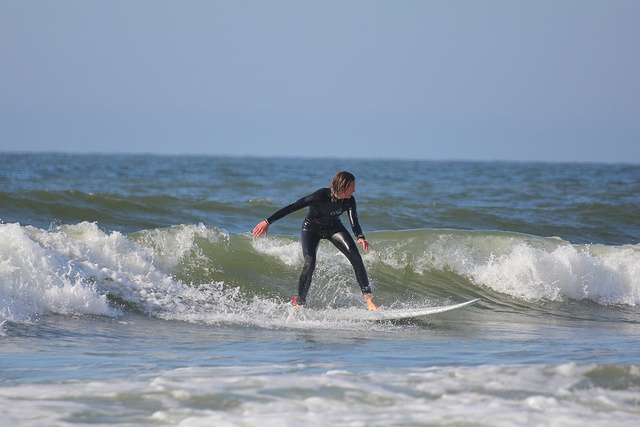Describe the objects in this image and their specific colors. I can see people in darkgray, black, and gray tones and surfboard in darkgray, lightgray, and gray tones in this image. 